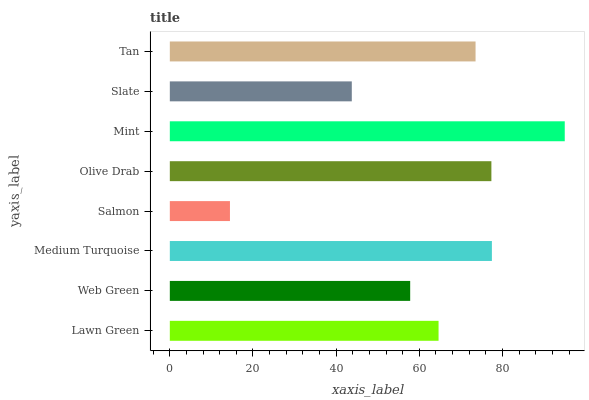Is Salmon the minimum?
Answer yes or no. Yes. Is Mint the maximum?
Answer yes or no. Yes. Is Web Green the minimum?
Answer yes or no. No. Is Web Green the maximum?
Answer yes or no. No. Is Lawn Green greater than Web Green?
Answer yes or no. Yes. Is Web Green less than Lawn Green?
Answer yes or no. Yes. Is Web Green greater than Lawn Green?
Answer yes or no. No. Is Lawn Green less than Web Green?
Answer yes or no. No. Is Tan the high median?
Answer yes or no. Yes. Is Lawn Green the low median?
Answer yes or no. Yes. Is Medium Turquoise the high median?
Answer yes or no. No. Is Medium Turquoise the low median?
Answer yes or no. No. 